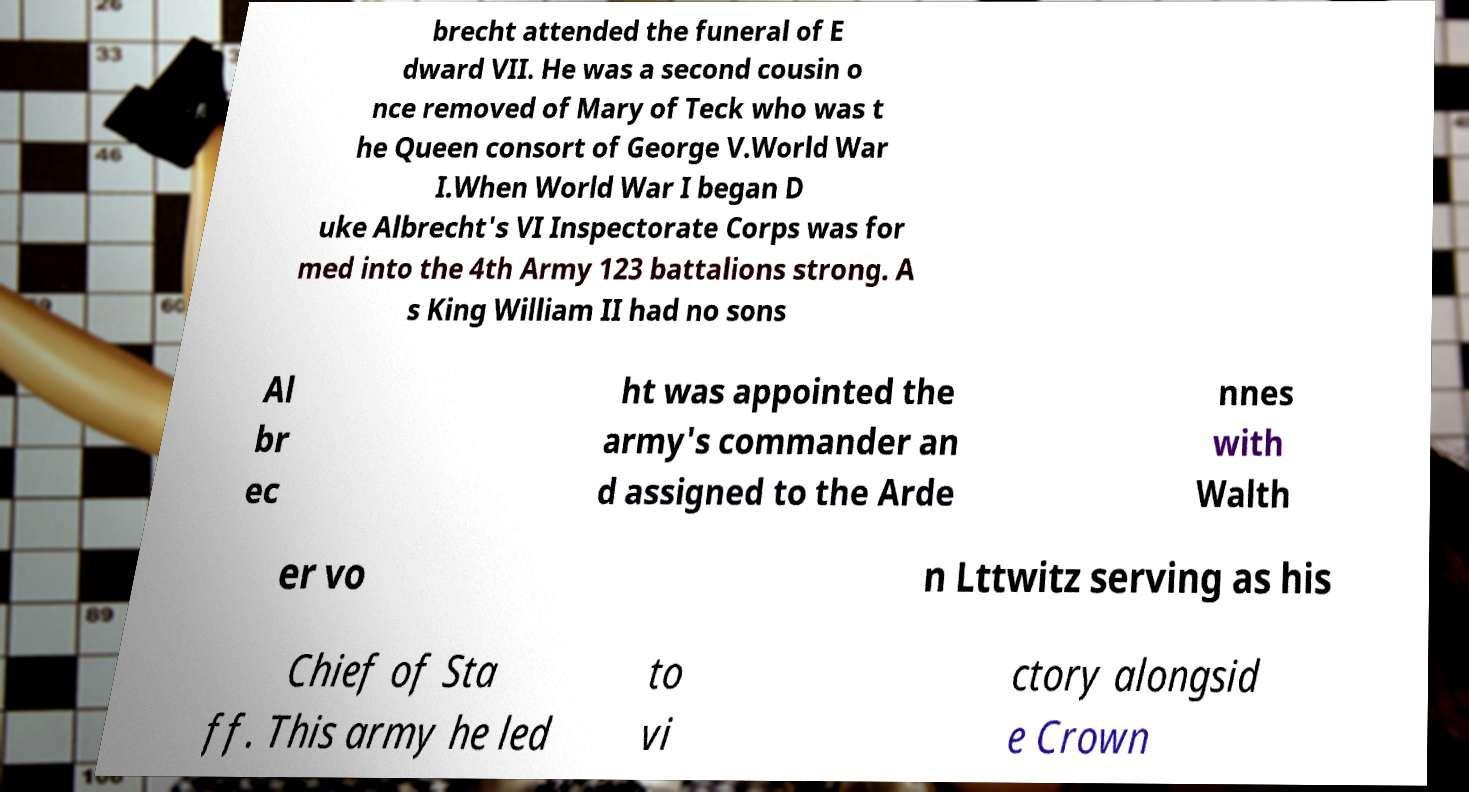Please identify and transcribe the text found in this image. brecht attended the funeral of E dward VII. He was a second cousin o nce removed of Mary of Teck who was t he Queen consort of George V.World War I.When World War I began D uke Albrecht's VI Inspectorate Corps was for med into the 4th Army 123 battalions strong. A s King William II had no sons Al br ec ht was appointed the army's commander an d assigned to the Arde nnes with Walth er vo n Lttwitz serving as his Chief of Sta ff. This army he led to vi ctory alongsid e Crown 